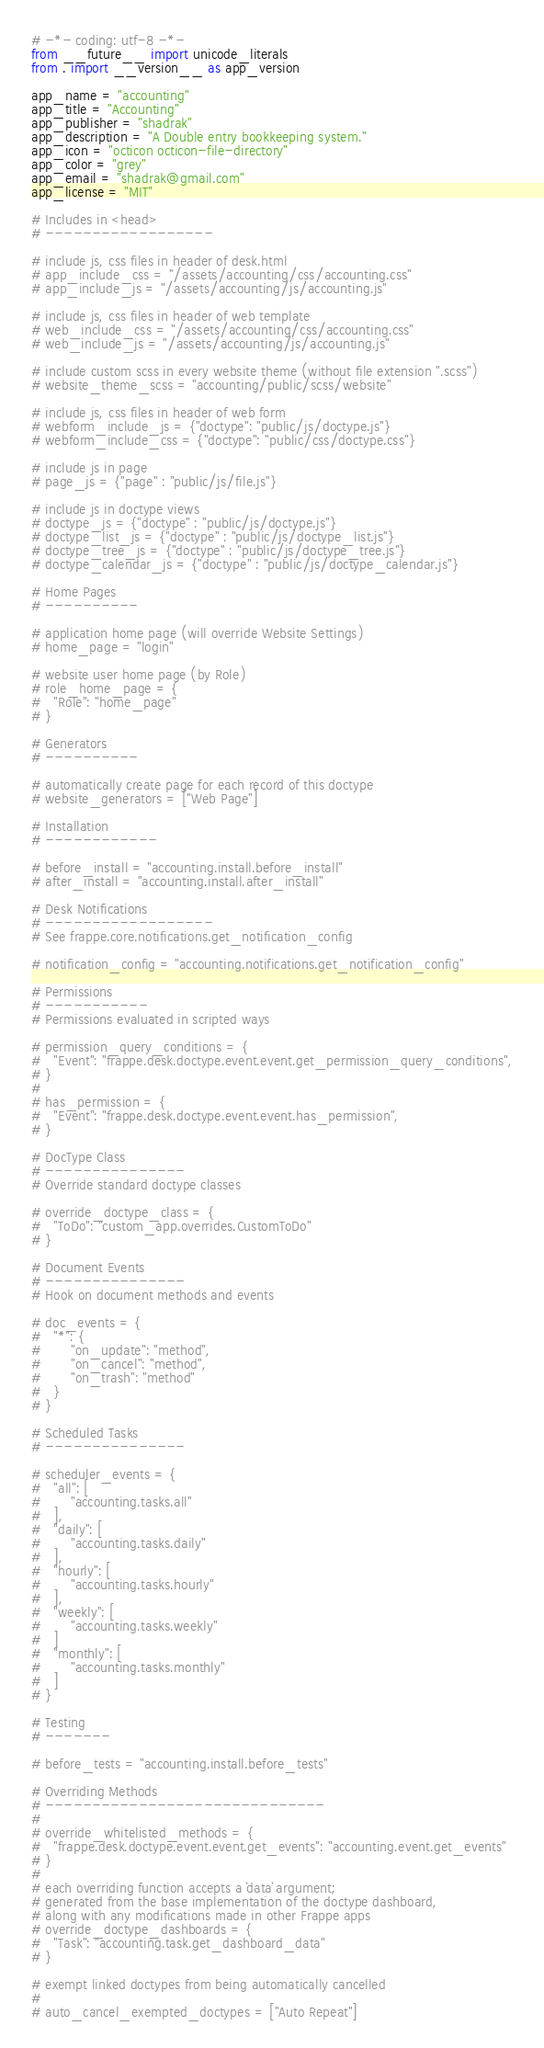<code> <loc_0><loc_0><loc_500><loc_500><_Python_># -*- coding: utf-8 -*-
from __future__ import unicode_literals
from . import __version__ as app_version

app_name = "accounting"
app_title = "Accounting"
app_publisher = "shadrak"
app_description = "A Double entry bookkeeping system."
app_icon = "octicon octicon-file-directory"
app_color = "grey"
app_email = "shadrak@gmail.com"
app_license = "MIT"

# Includes in <head>
# ------------------

# include js, css files in header of desk.html
# app_include_css = "/assets/accounting/css/accounting.css"
# app_include_js = "/assets/accounting/js/accounting.js"

# include js, css files in header of web template
# web_include_css = "/assets/accounting/css/accounting.css"
# web_include_js = "/assets/accounting/js/accounting.js"

# include custom scss in every website theme (without file extension ".scss")
# website_theme_scss = "accounting/public/scss/website"

# include js, css files in header of web form
# webform_include_js = {"doctype": "public/js/doctype.js"}
# webform_include_css = {"doctype": "public/css/doctype.css"}

# include js in page
# page_js = {"page" : "public/js/file.js"}

# include js in doctype views
# doctype_js = {"doctype" : "public/js/doctype.js"}
# doctype_list_js = {"doctype" : "public/js/doctype_list.js"}
# doctype_tree_js = {"doctype" : "public/js/doctype_tree.js"}
# doctype_calendar_js = {"doctype" : "public/js/doctype_calendar.js"}

# Home Pages
# ----------

# application home page (will override Website Settings)
# home_page = "login"

# website user home page (by Role)
# role_home_page = {
#	"Role": "home_page"
# }

# Generators
# ----------

# automatically create page for each record of this doctype
# website_generators = ["Web Page"]

# Installation
# ------------

# before_install = "accounting.install.before_install"
# after_install = "accounting.install.after_install"

# Desk Notifications
# ------------------
# See frappe.core.notifications.get_notification_config

# notification_config = "accounting.notifications.get_notification_config"

# Permissions
# -----------
# Permissions evaluated in scripted ways

# permission_query_conditions = {
# 	"Event": "frappe.desk.doctype.event.event.get_permission_query_conditions",
# }
#
# has_permission = {
# 	"Event": "frappe.desk.doctype.event.event.has_permission",
# }

# DocType Class
# ---------------
# Override standard doctype classes

# override_doctype_class = {
# 	"ToDo": "custom_app.overrides.CustomToDo"
# }

# Document Events
# ---------------
# Hook on document methods and events

# doc_events = {
# 	"*": {
# 		"on_update": "method",
# 		"on_cancel": "method",
# 		"on_trash": "method"
#	}
# }

# Scheduled Tasks
# ---------------

# scheduler_events = {
# 	"all": [
# 		"accounting.tasks.all"
# 	],
# 	"daily": [
# 		"accounting.tasks.daily"
# 	],
# 	"hourly": [
# 		"accounting.tasks.hourly"
# 	],
# 	"weekly": [
# 		"accounting.tasks.weekly"
# 	]
# 	"monthly": [
# 		"accounting.tasks.monthly"
# 	]
# }

# Testing
# -------

# before_tests = "accounting.install.before_tests"

# Overriding Methods
# ------------------------------
#
# override_whitelisted_methods = {
# 	"frappe.desk.doctype.event.event.get_events": "accounting.event.get_events"
# }
#
# each overriding function accepts a `data` argument;
# generated from the base implementation of the doctype dashboard,
# along with any modifications made in other Frappe apps
# override_doctype_dashboards = {
# 	"Task": "accounting.task.get_dashboard_data"
# }

# exempt linked doctypes from being automatically cancelled
#
# auto_cancel_exempted_doctypes = ["Auto Repeat"]

</code> 